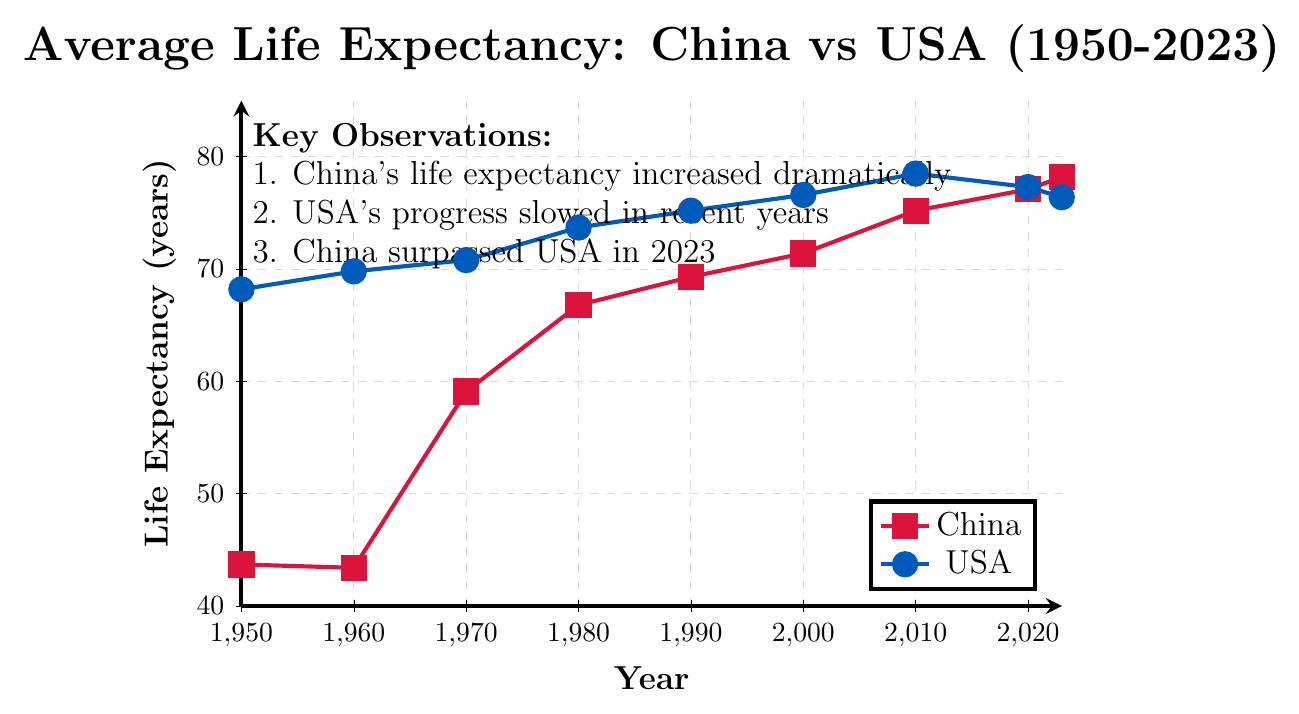What is the trend in life expectancy for China from 1950 to 2023? From the figure, we can observe the data points for China for each decade and see that the life expectancy generally increases from 43.7 in 1950 to 78.2 in 2023. This trend shows a gradual increase.
Answer: Increasing Which year did China's life expectancy surpass the US's life expectancy? Looking at the plotted lines for both countries, we can see that in 2023, China's life expectancy at 78.2 surpassed the US at 76.4.
Answer: 2023 What was the difference in life expectancy between China and the USA in 1950? In 1950, the life expectancy for China was 43.7 and for the USA was 68.2. Subtracting these values, 68.2 - 43.7, gives the difference.
Answer: 24.5 years During which decade did China see the most significant increase in life expectancy? By examining the increments between each decade for China, the increase from 1960 (43.4) to 1970 (59.1) is the largest, with a difference of 15.7 years.
Answer: 1960 to 1970 What is the average life expectancy for the USA over the given years (1950-2023)? Adding the life expectancy values for the USA from 1950 to 2023 (68.2 + 69.8 + 70.8 + 73.7 + 75.2 + 76.6 + 78.5 + 77.3 + 76.4) and then dividing by the number of points (9) results in an average. Sum is 666.5 and the average is 666.5/9.
Answer: 74.1 years How does the trend for life expectancy in the USA from 1950 to 2023 compare to China? Both lines show an upward trend over the years, but China's life expectancy shows a more dramatic increase while the USA's life expectancy increases slowly and even declines in recent years.
Answer: China's trend is steeper and surpasses the USA in recent years Based on the figure, which country had a more stable life expectancy trend from 1950 to 2023? The line for the USA shows a smoother and more stable pattern with less dramatic changes compared to China's line, which shows significant rises, particularly between 1960 and 1970.
Answer: USA What was the life expectancy in China in 1980 and how does it compare with that in 1970? According to the figure, the life expectancy in China in 1980 was 66.8, and in 1970 it was 59.1. The difference is 66.8 - 59.1.
Answer: 7.7 years higher Which year marks the smallest gap between life expectancy in China and the USA before 2023? Comparing the differences for each year from both lines, in 2020 the gap is the smallest before 2023. The life expectancy for China is 77.1 and for the USA is 77.3, so the gap is 77.3 - 77.1.
Answer: 0.2 years Looking at the overall figure, what key observation can be made about life expectancy trends in both countries? One of the annotations in the figure highlights key points such as China's dramatic increase, the USA's slowing progress in recent years, and China surpassing the USA in 2023.
Answer: Dramatic increase in China, slowing progress in the USA, China surpassed the USA in 2023 